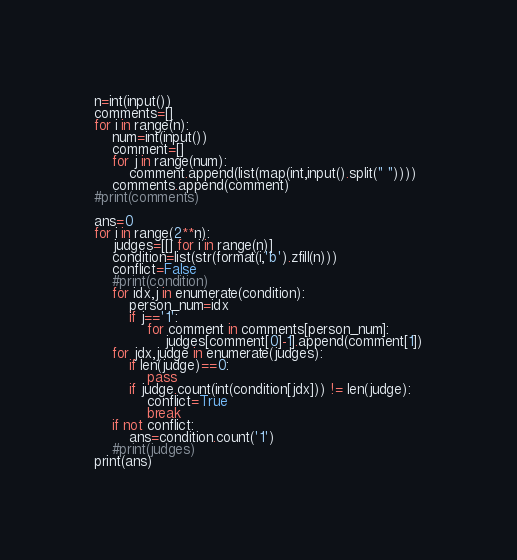<code> <loc_0><loc_0><loc_500><loc_500><_Python_>n=int(input())
comments=[]
for i in range(n):
    num=int(input())
    comment=[]
    for j in range(num):
        comment.append(list(map(int,input().split(" "))))
    comments.append(comment)
#print(comments)

ans=0
for i in range(2**n):
    judges=[[] for i in range(n)]
    condition=list(str(format(i,'b').zfill(n)))
    conflict=False
    #print(condition)
    for idx,j in enumerate(condition):
        person_num=idx
        if j=='1':
            for comment in comments[person_num]:
                judges[comment[0]-1].append(comment[1])
    for jdx,judge in enumerate(judges):
        if len(judge)==0:
            pass
        if judge.count(int(condition[jdx])) != len(judge):
            conflict=True
            break
    if not conflict:
        ans=condition.count('1')
    #print(judges)
print(ans)</code> 